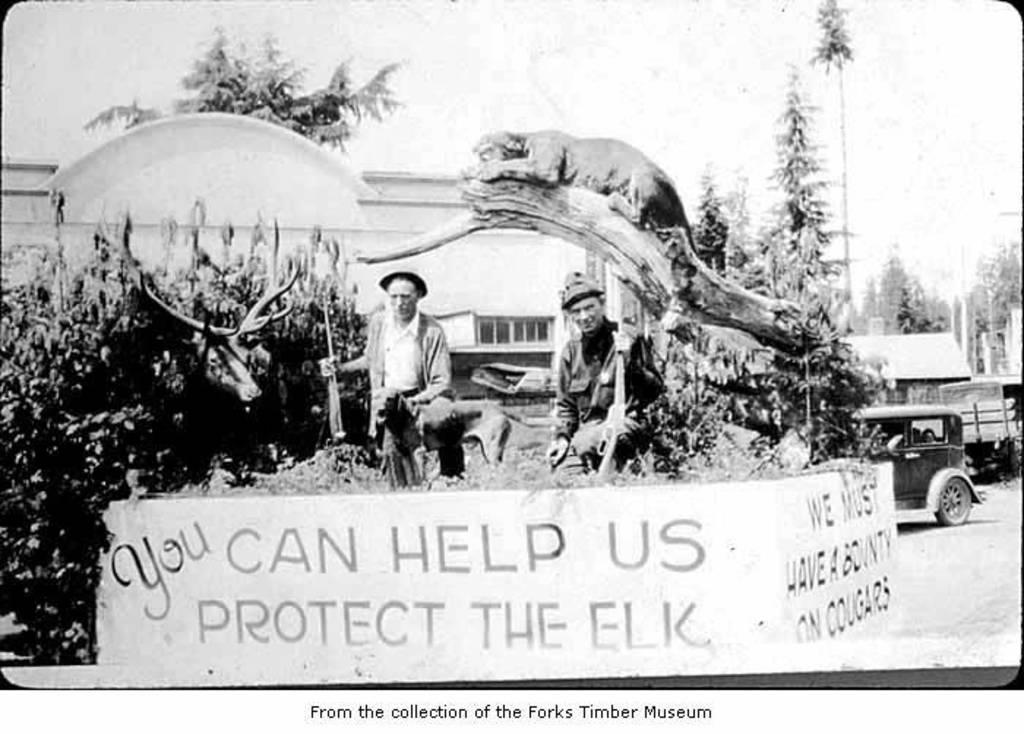How would you summarize this image in a sentence or two? This image consists of two persons. At the bottom, there is a text. On the right, we can see a vehicle on the road. On the left, there are plants. In the background, there are trees and a building. And we can see an animal on the branch of a tree. 